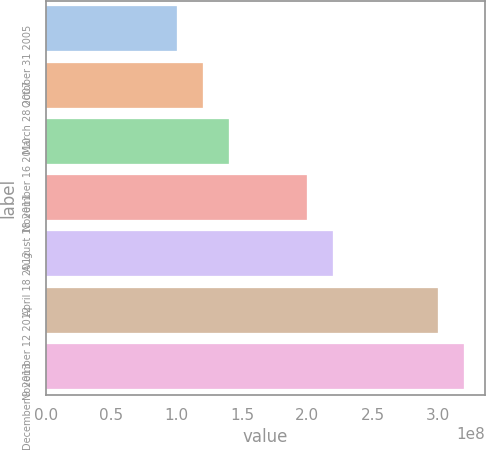Convert chart to OTSL. <chart><loc_0><loc_0><loc_500><loc_500><bar_chart><fcel>October 31 2005<fcel>March 28 2007<fcel>November 16 2010<fcel>August 18 2011<fcel>April 18 2012<fcel>November 12 2012<fcel>December 9 2013<nl><fcel>1e+08<fcel>1.2e+08<fcel>1.4e+08<fcel>2e+08<fcel>2.2e+08<fcel>3e+08<fcel>3.2e+08<nl></chart> 